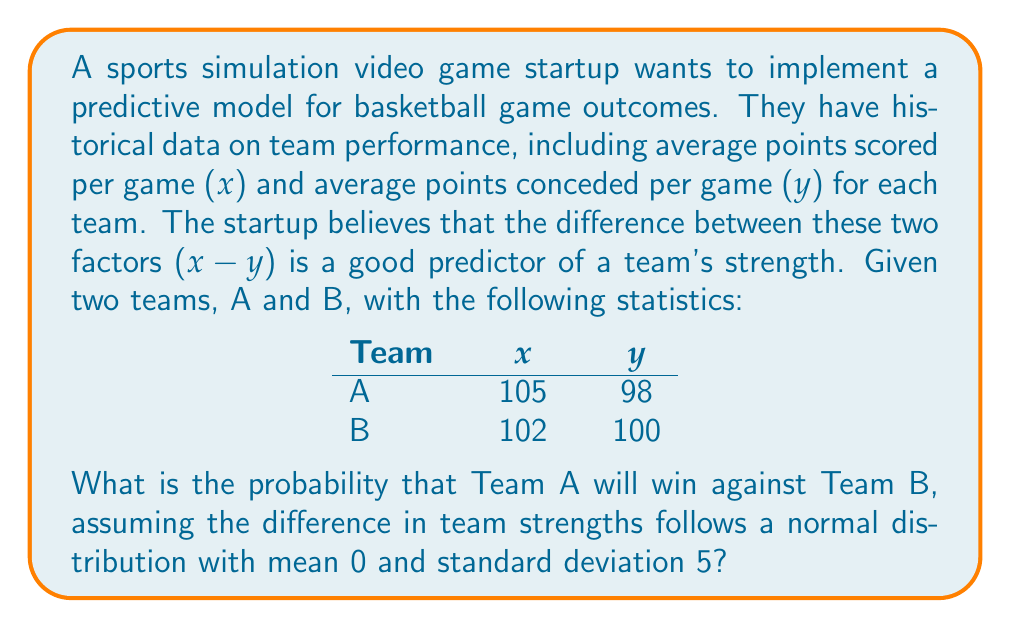Show me your answer to this math problem. To solve this problem, we'll follow these steps:

1. Calculate the strength of each team:
   Team A strength: $S_A = x_A - y_A = 105 - 98 = 7$
   Team B strength: $S_B = x_B - y_B = 102 - 100 = 2$

2. Calculate the difference in team strengths:
   $\Delta S = S_A - S_B = 7 - 2 = 5$

3. Since the difference in team strengths follows a normal distribution with mean 0 and standard deviation 5, we can calculate the z-score:
   $z = \frac{\Delta S - \mu}{\sigma} = \frac{5 - 0}{5} = 1$

4. The probability that Team A wins is equivalent to the probability that the difference in strengths is greater than 0. This is represented by the area under the normal curve to the right of z = 0.

5. Using the standard normal distribution table or a calculator, we can find the area to the right of z = 1:
   $P(Z > 1) = 1 - P(Z \leq 1) = 1 - 0.8413 = 0.1587$

6. The probability that Team A wins is:
   $P(\text{Team A wins}) = 0.5 + 0.1587 = 0.6587$

This is because the probability of Team A winning includes half of the probability at exactly z = 0 (tied strength) plus the probability of having a higher strength.
Answer: 0.6587 